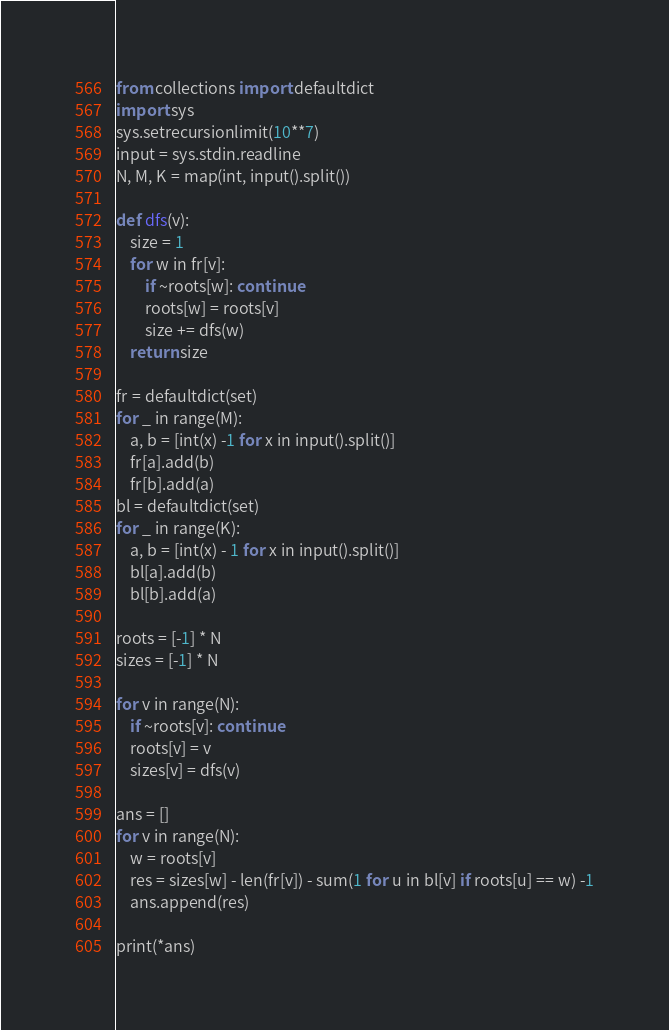Convert code to text. <code><loc_0><loc_0><loc_500><loc_500><_Python_>from collections import defaultdict
import sys
sys.setrecursionlimit(10**7)
input = sys.stdin.readline
N, M, K = map(int, input().split())

def dfs(v):
    size = 1
    for w in fr[v]:
        if ~roots[w]: continue
        roots[w] = roots[v]
        size += dfs(w)
    return size

fr = defaultdict(set)
for _ in range(M):
    a, b = [int(x) -1 for x in input().split()]
    fr[a].add(b)
    fr[b].add(a)
bl = defaultdict(set)
for _ in range(K):
    a, b = [int(x) - 1 for x in input().split()]
    bl[a].add(b)
    bl[b].add(a)

roots = [-1] * N
sizes = [-1] * N

for v in range(N):
    if ~roots[v]: continue
    roots[v] = v
    sizes[v] = dfs(v)

ans = []
for v in range(N):
    w = roots[v]
    res = sizes[w] - len(fr[v]) - sum(1 for u in bl[v] if roots[u] == w) -1
    ans.append(res)

print(*ans)</code> 